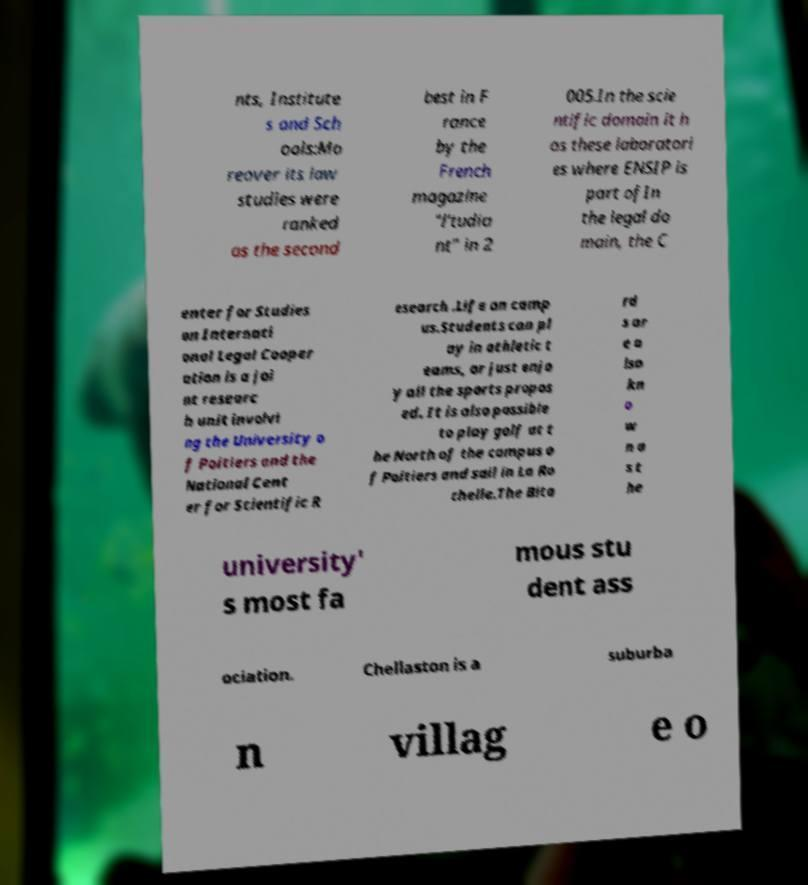I need the written content from this picture converted into text. Can you do that? nts, Institute s and Sch ools:Mo reover its law studies were ranked as the second best in F rance by the French magazine "l'tudia nt" in 2 005.In the scie ntific domain it h as these laboratori es where ENSIP is part ofIn the legal do main, the C enter for Studies on Internati onal Legal Cooper ation is a joi nt researc h unit involvi ng the University o f Poitiers and the National Cent er for Scientific R esearch .Life on camp us.Students can pl ay in athletic t eams, or just enjo y all the sports propos ed. It is also possible to play golf at t he North of the campus o f Poitiers and sail in La Ro chelle.The Bita rd s ar e a lso kn o w n a s t he university' s most fa mous stu dent ass ociation. Chellaston is a suburba n villag e o 